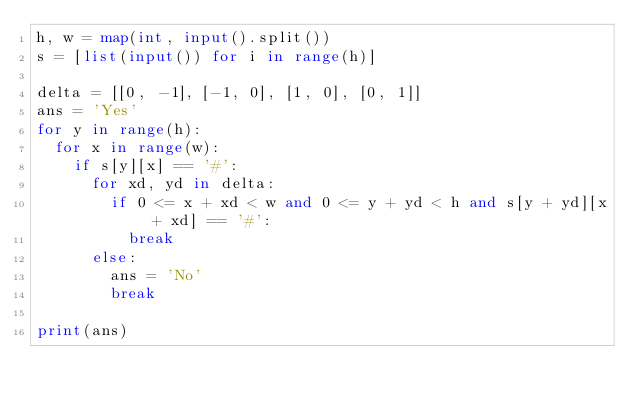Convert code to text. <code><loc_0><loc_0><loc_500><loc_500><_Python_>h, w = map(int, input().split())
s = [list(input()) for i in range(h)]

delta = [[0, -1], [-1, 0], [1, 0], [0, 1]]
ans = 'Yes'
for y in range(h):
  for x in range(w):
    if s[y][x] == '#':
      for xd, yd in delta:
        if 0 <= x + xd < w and 0 <= y + yd < h and s[y + yd][x + xd] == '#':
          break
      else:
        ans = 'No'
        break

print(ans)</code> 